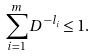<formula> <loc_0><loc_0><loc_500><loc_500>\sum _ { i = 1 } ^ { m } D ^ { - l _ { i } } \leq 1 .</formula> 